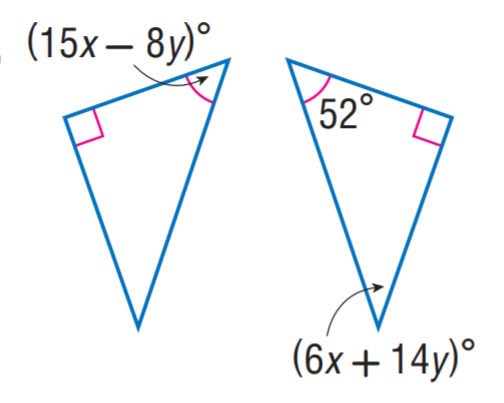Answer the mathemtical geometry problem and directly provide the correct option letter.
Question: Find y.
Choices: A: 1 B: 2 C: 3 D: 4 A 